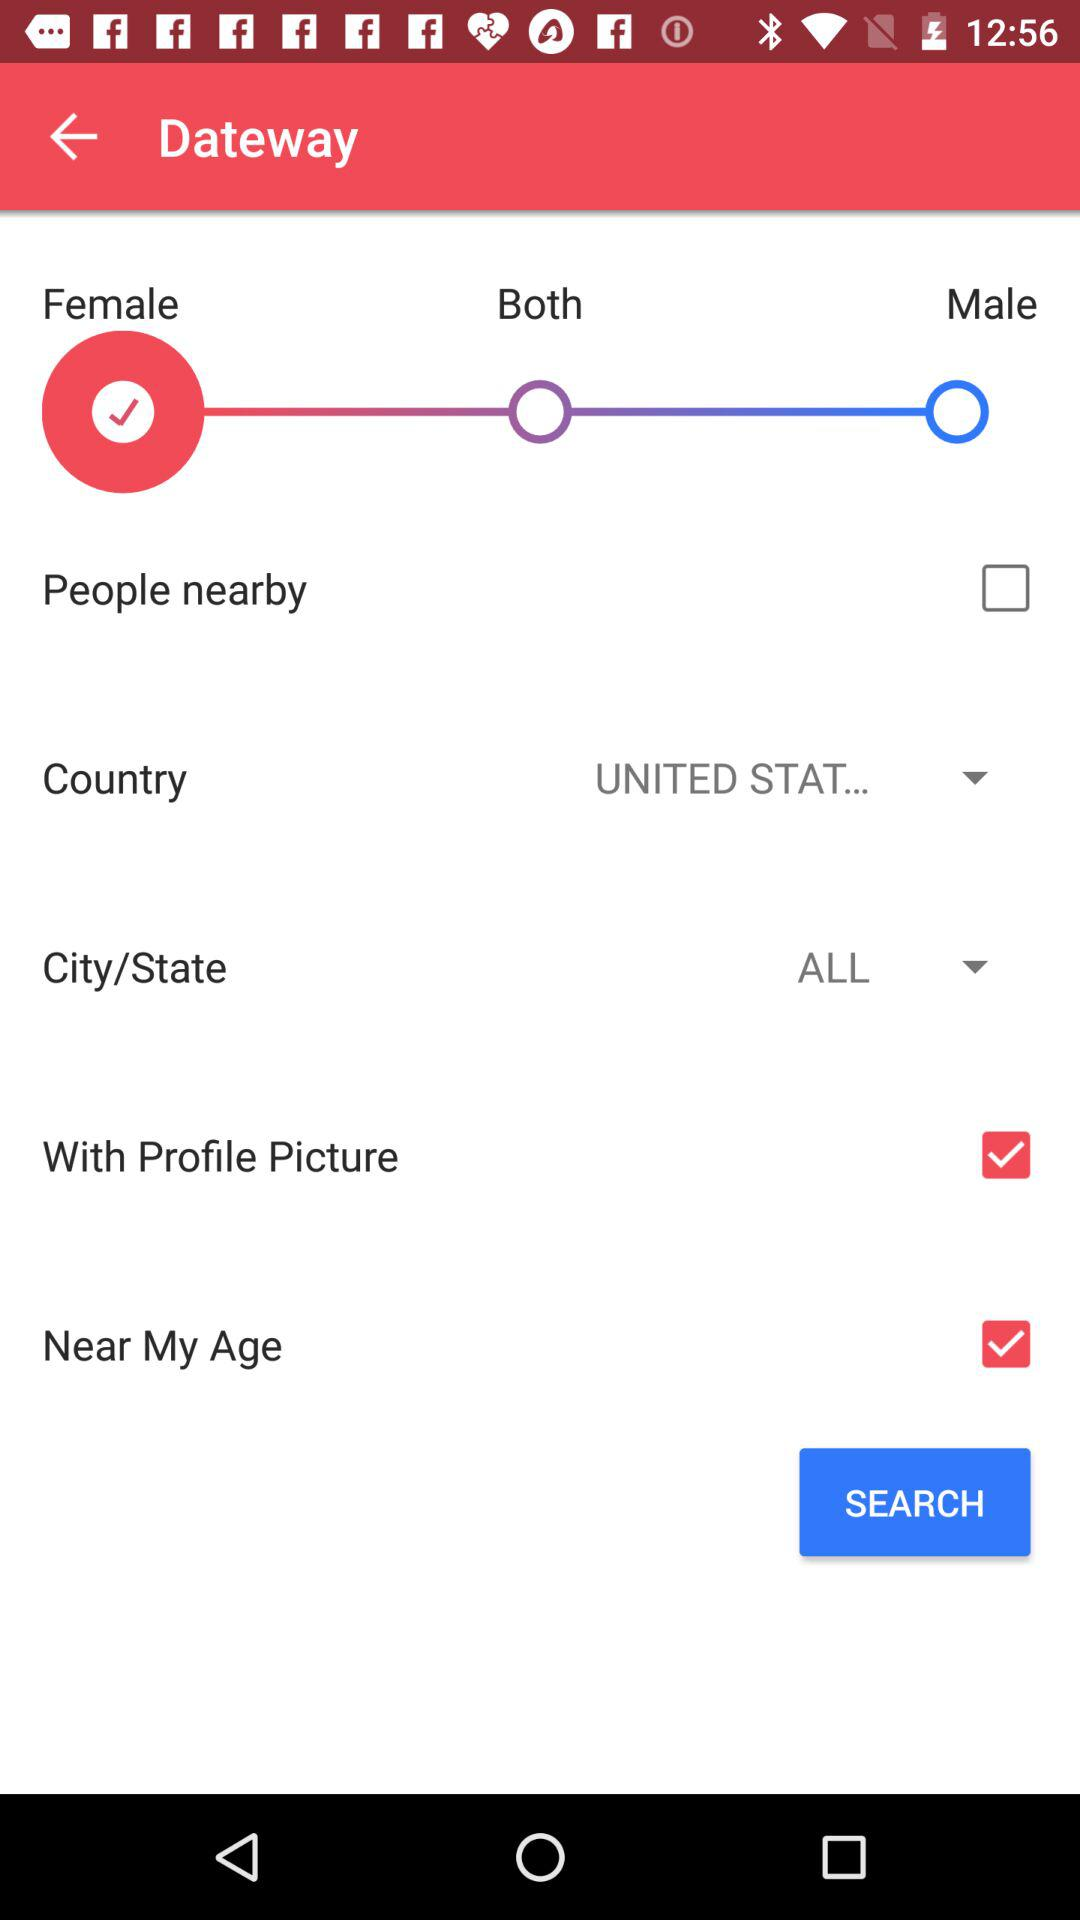What is the name of the application? The name of the application is "Dateway". 